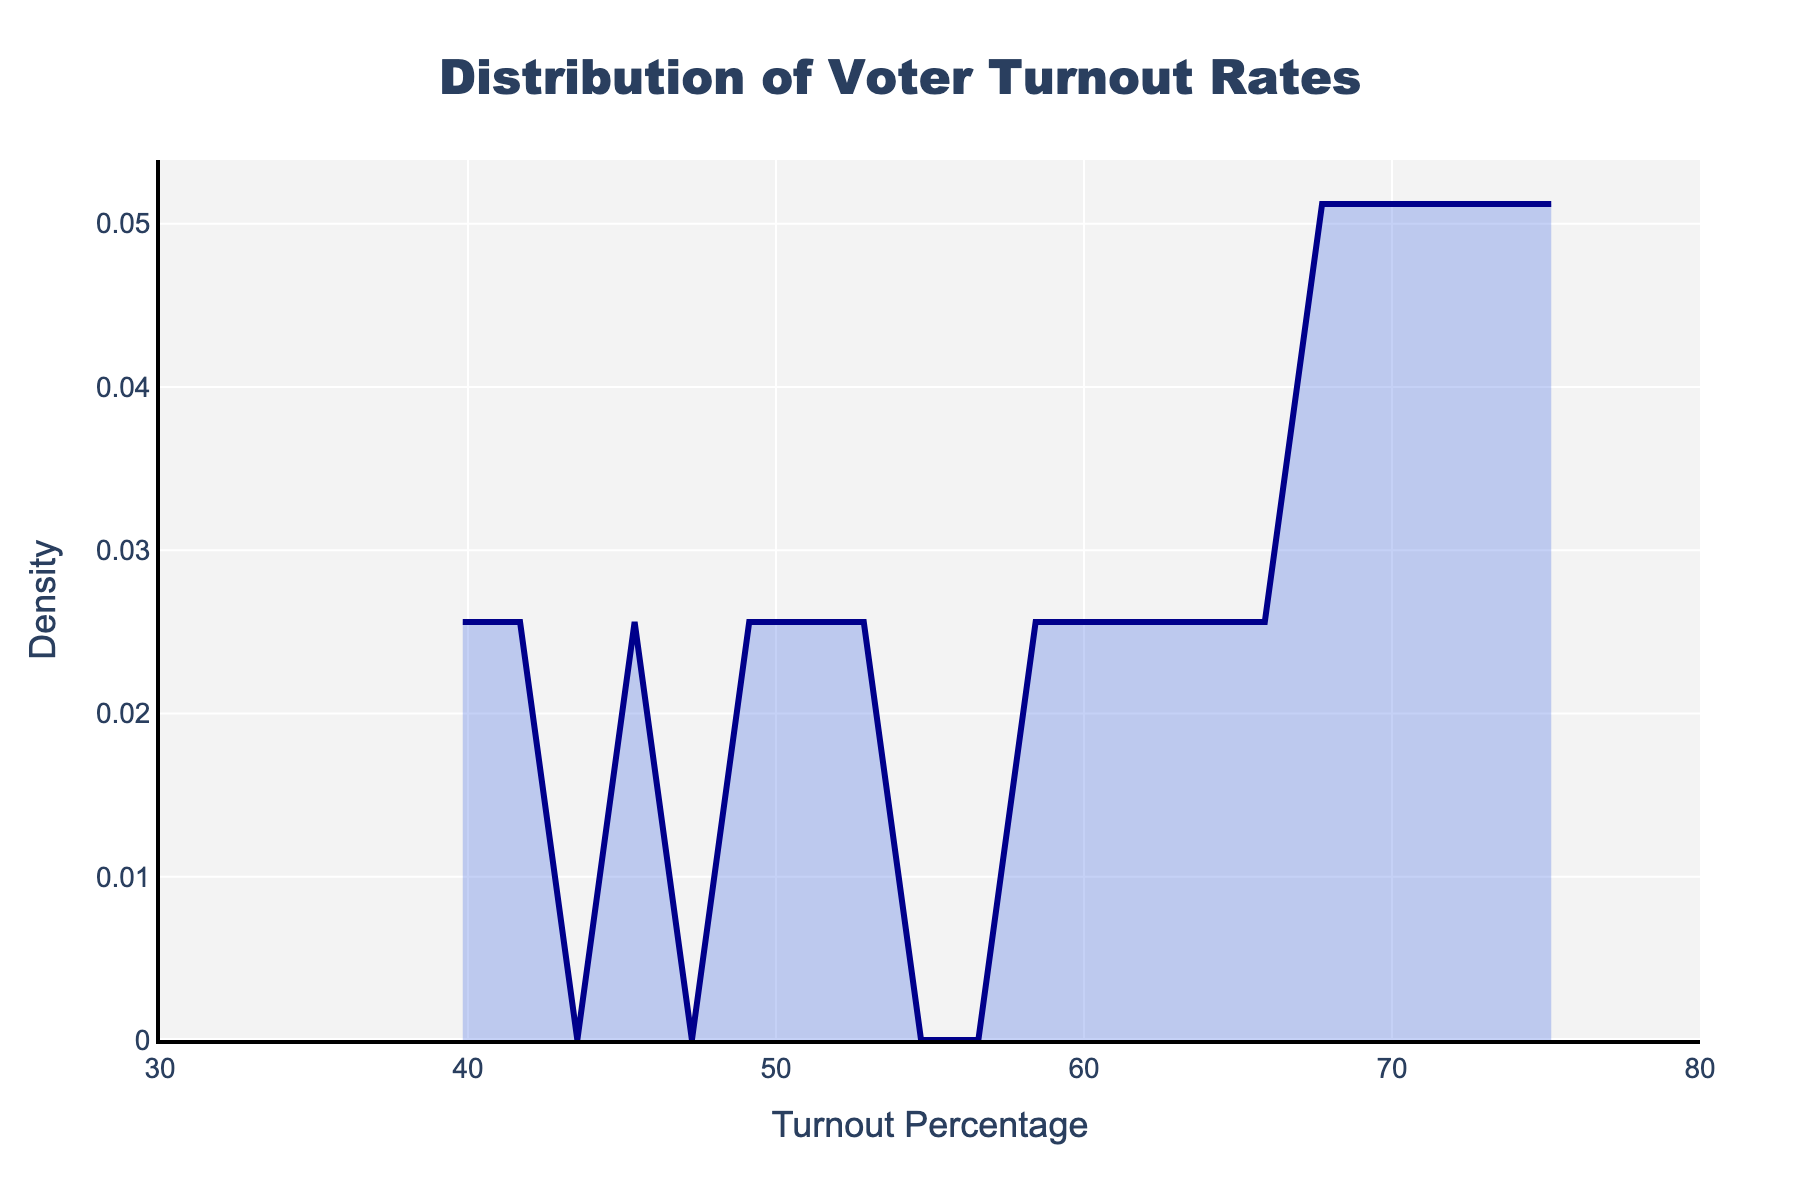What's the title of the plot? The title is displayed at the top of the plot, usually in a larger and bold font, indicating the main subject of the figure. In this case, it reads "Distribution of Voter Turnout Rates."
Answer: Distribution of Voter Turnout Rates What is the x-axis label? The x-axis label is positioned along the horizontal axis of the plot, describing the variable shown on this axis. It is labeled as "Turnout Percentage."
Answer: Turnout Percentage What is the y-axis label? The y-axis label is positioned along the vertical axis of the plot, describing the variable shown on this axis. It is labeled as "Density."
Answer: Density What is the range of the x-axis? The range of the x-axis is indicated by the values at the ends of the x-axis. It spans from 30 to 80.
Answer: 30 to 80 How does the density change around a turnout rate of 60%? To identify the density around a particular turnout rate, locate 60% on the x-axis, then observe the y-axis value directly above it. The density appears to peak around this value.
Answer: It peaks Which age group has the lowest voter turnout rates generally? To find this, compare the voter turnout percentages given for each age group. The 18-24 age group has the lowest turnout percentages across the data points.
Answer: 18-24 Which age group shows the highest voter turnout rates generally? Comparing the voter turnout percentages across different age groups, the 65-74 age group shows the highest turnout rates generally.
Answer: 65-74 Is the overall trend of voter turnout increasing or decreasing with age? By analyzing the turnout percentages across different age groups, we can observe that voter turnout generally increases with age up until the 65-74 group, after which it slightly decreases.
Answer: Increasing up to 65-74 What is the average voter turnout percentage for the 35-44 age group? To find the average, sum the turnout percentages for the 35-44 age group and divide by the number of data points: (59.8 + 57.6 + 61.4) / 3 = 59.6%.
Answer: 59.6% How does the voter turnout for the 75+ age group compare to the 55-64 age group? Compare the turnout percentages of both groups. The 75+ group has slightly lower turnout percentages on average compared to the 55-64 age group.
Answer: Slightly lower 